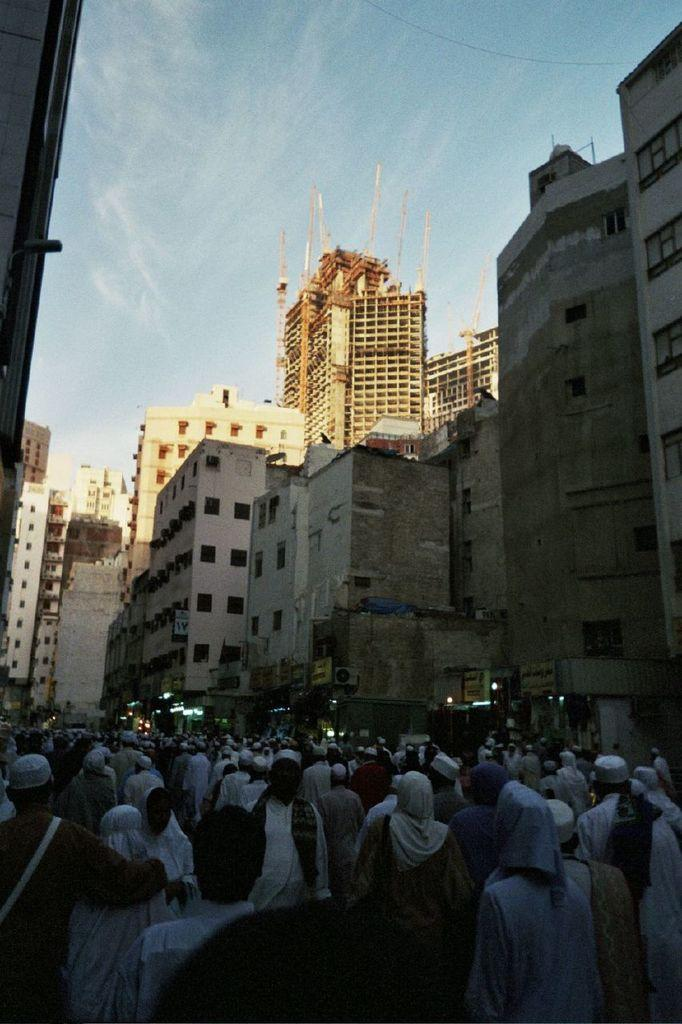What are the people in the image doing? The people in the image are standing on a path. What can be seen in the distance behind the people? There are buildings visible in the background of the image. What else is visible in the background of the image? The sky is visible in the background of the image. What type of silver jellyfish can be seen floating in the sky in the image? There is no silver jellyfish present in the image; the sky is visible but does not contain any jellyfish. 